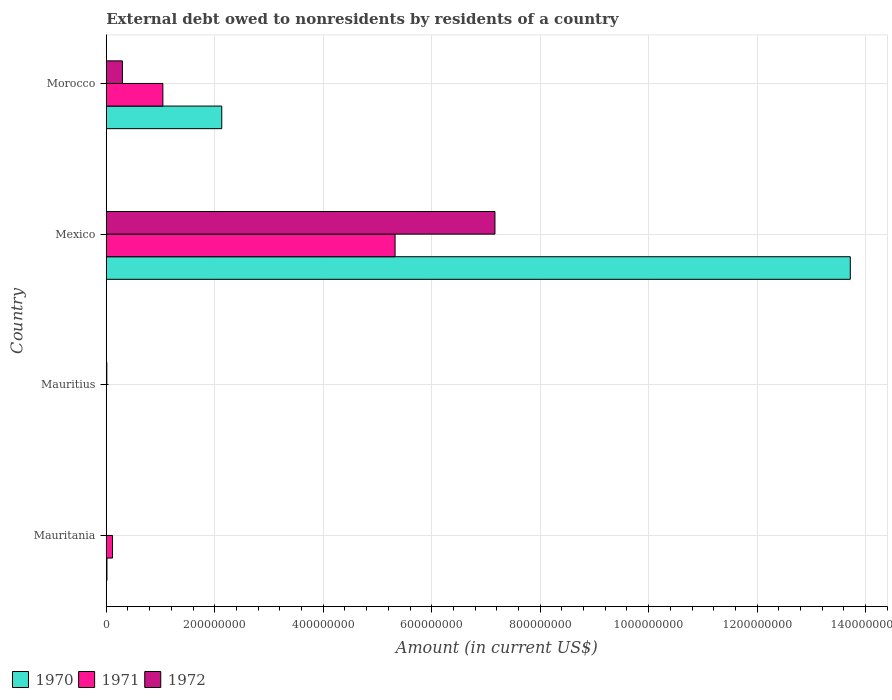How many different coloured bars are there?
Your response must be concise. 3. Are the number of bars on each tick of the Y-axis equal?
Ensure brevity in your answer.  No. How many bars are there on the 4th tick from the bottom?
Your answer should be compact. 3. In how many cases, is the number of bars for a given country not equal to the number of legend labels?
Keep it short and to the point. 2. What is the external debt owed by residents in 1970 in Mauritius?
Your response must be concise. 0. Across all countries, what is the maximum external debt owed by residents in 1971?
Give a very brief answer. 5.32e+08. In which country was the external debt owed by residents in 1970 maximum?
Your answer should be compact. Mexico. What is the total external debt owed by residents in 1970 in the graph?
Ensure brevity in your answer.  1.59e+09. What is the difference between the external debt owed by residents in 1971 in Mauritania and that in Morocco?
Offer a terse response. -9.29e+07. What is the difference between the external debt owed by residents in 1971 in Mauritius and the external debt owed by residents in 1970 in Morocco?
Your answer should be very brief. -2.13e+08. What is the average external debt owed by residents in 1971 per country?
Your answer should be compact. 1.62e+08. What is the difference between the external debt owed by residents in 1970 and external debt owed by residents in 1972 in Morocco?
Offer a very short reply. 1.83e+08. What is the ratio of the external debt owed by residents in 1972 in Mauritius to that in Mexico?
Your answer should be compact. 0. Is the external debt owed by residents in 1971 in Mexico less than that in Morocco?
Provide a short and direct response. No. What is the difference between the highest and the second highest external debt owed by residents in 1971?
Ensure brevity in your answer.  4.28e+08. What is the difference between the highest and the lowest external debt owed by residents in 1970?
Give a very brief answer. 1.37e+09. In how many countries, is the external debt owed by residents in 1972 greater than the average external debt owed by residents in 1972 taken over all countries?
Keep it short and to the point. 1. Is the sum of the external debt owed by residents in 1970 in Mauritania and Morocco greater than the maximum external debt owed by residents in 1971 across all countries?
Provide a short and direct response. No. How many bars are there?
Offer a terse response. 9. What is the difference between two consecutive major ticks on the X-axis?
Provide a short and direct response. 2.00e+08. Are the values on the major ticks of X-axis written in scientific E-notation?
Your answer should be very brief. No. Where does the legend appear in the graph?
Your answer should be very brief. Bottom left. How are the legend labels stacked?
Your response must be concise. Horizontal. What is the title of the graph?
Your answer should be very brief. External debt owed to nonresidents by residents of a country. Does "1998" appear as one of the legend labels in the graph?
Provide a short and direct response. No. What is the label or title of the X-axis?
Your answer should be very brief. Amount (in current US$). What is the label or title of the Y-axis?
Keep it short and to the point. Country. What is the Amount (in current US$) in 1970 in Mauritania?
Your answer should be very brief. 1.34e+06. What is the Amount (in current US$) in 1971 in Mauritania?
Your response must be concise. 1.15e+07. What is the Amount (in current US$) in 1972 in Mauritania?
Provide a succinct answer. 0. What is the Amount (in current US$) in 1972 in Mauritius?
Keep it short and to the point. 1.06e+06. What is the Amount (in current US$) in 1970 in Mexico?
Provide a short and direct response. 1.37e+09. What is the Amount (in current US$) of 1971 in Mexico?
Offer a very short reply. 5.32e+08. What is the Amount (in current US$) in 1972 in Mexico?
Make the answer very short. 7.17e+08. What is the Amount (in current US$) of 1970 in Morocco?
Provide a succinct answer. 2.13e+08. What is the Amount (in current US$) of 1971 in Morocco?
Keep it short and to the point. 1.04e+08. What is the Amount (in current US$) of 1972 in Morocco?
Ensure brevity in your answer.  2.98e+07. Across all countries, what is the maximum Amount (in current US$) in 1970?
Ensure brevity in your answer.  1.37e+09. Across all countries, what is the maximum Amount (in current US$) in 1971?
Your answer should be compact. 5.32e+08. Across all countries, what is the maximum Amount (in current US$) in 1972?
Your response must be concise. 7.17e+08. Across all countries, what is the minimum Amount (in current US$) in 1970?
Ensure brevity in your answer.  0. Across all countries, what is the minimum Amount (in current US$) of 1972?
Provide a succinct answer. 0. What is the total Amount (in current US$) in 1970 in the graph?
Make the answer very short. 1.59e+09. What is the total Amount (in current US$) in 1971 in the graph?
Your response must be concise. 6.48e+08. What is the total Amount (in current US$) in 1972 in the graph?
Offer a terse response. 7.47e+08. What is the difference between the Amount (in current US$) of 1970 in Mauritania and that in Mexico?
Provide a succinct answer. -1.37e+09. What is the difference between the Amount (in current US$) of 1971 in Mauritania and that in Mexico?
Keep it short and to the point. -5.21e+08. What is the difference between the Amount (in current US$) of 1970 in Mauritania and that in Morocco?
Provide a short and direct response. -2.12e+08. What is the difference between the Amount (in current US$) of 1971 in Mauritania and that in Morocco?
Offer a terse response. -9.29e+07. What is the difference between the Amount (in current US$) in 1972 in Mauritius and that in Mexico?
Offer a terse response. -7.16e+08. What is the difference between the Amount (in current US$) in 1972 in Mauritius and that in Morocco?
Your response must be concise. -2.88e+07. What is the difference between the Amount (in current US$) in 1970 in Mexico and that in Morocco?
Your answer should be compact. 1.16e+09. What is the difference between the Amount (in current US$) of 1971 in Mexico and that in Morocco?
Keep it short and to the point. 4.28e+08. What is the difference between the Amount (in current US$) in 1972 in Mexico and that in Morocco?
Provide a short and direct response. 6.87e+08. What is the difference between the Amount (in current US$) in 1970 in Mauritania and the Amount (in current US$) in 1972 in Mauritius?
Offer a terse response. 2.82e+05. What is the difference between the Amount (in current US$) of 1971 in Mauritania and the Amount (in current US$) of 1972 in Mauritius?
Offer a very short reply. 1.05e+07. What is the difference between the Amount (in current US$) of 1970 in Mauritania and the Amount (in current US$) of 1971 in Mexico?
Offer a very short reply. -5.31e+08. What is the difference between the Amount (in current US$) of 1970 in Mauritania and the Amount (in current US$) of 1972 in Mexico?
Offer a very short reply. -7.15e+08. What is the difference between the Amount (in current US$) of 1971 in Mauritania and the Amount (in current US$) of 1972 in Mexico?
Your answer should be very brief. -7.05e+08. What is the difference between the Amount (in current US$) of 1970 in Mauritania and the Amount (in current US$) of 1971 in Morocco?
Provide a short and direct response. -1.03e+08. What is the difference between the Amount (in current US$) of 1970 in Mauritania and the Amount (in current US$) of 1972 in Morocco?
Offer a very short reply. -2.85e+07. What is the difference between the Amount (in current US$) of 1971 in Mauritania and the Amount (in current US$) of 1972 in Morocco?
Ensure brevity in your answer.  -1.83e+07. What is the difference between the Amount (in current US$) in 1970 in Mexico and the Amount (in current US$) in 1971 in Morocco?
Your answer should be very brief. 1.27e+09. What is the difference between the Amount (in current US$) in 1970 in Mexico and the Amount (in current US$) in 1972 in Morocco?
Your answer should be compact. 1.34e+09. What is the difference between the Amount (in current US$) of 1971 in Mexico and the Amount (in current US$) of 1972 in Morocco?
Provide a short and direct response. 5.03e+08. What is the average Amount (in current US$) in 1970 per country?
Your answer should be very brief. 3.97e+08. What is the average Amount (in current US$) of 1971 per country?
Offer a terse response. 1.62e+08. What is the average Amount (in current US$) in 1972 per country?
Provide a short and direct response. 1.87e+08. What is the difference between the Amount (in current US$) of 1970 and Amount (in current US$) of 1971 in Mauritania?
Your answer should be compact. -1.02e+07. What is the difference between the Amount (in current US$) in 1970 and Amount (in current US$) in 1971 in Mexico?
Your answer should be very brief. 8.39e+08. What is the difference between the Amount (in current US$) in 1970 and Amount (in current US$) in 1972 in Mexico?
Offer a very short reply. 6.55e+08. What is the difference between the Amount (in current US$) of 1971 and Amount (in current US$) of 1972 in Mexico?
Your answer should be compact. -1.84e+08. What is the difference between the Amount (in current US$) of 1970 and Amount (in current US$) of 1971 in Morocco?
Ensure brevity in your answer.  1.09e+08. What is the difference between the Amount (in current US$) in 1970 and Amount (in current US$) in 1972 in Morocco?
Your answer should be very brief. 1.83e+08. What is the difference between the Amount (in current US$) in 1971 and Amount (in current US$) in 1972 in Morocco?
Give a very brief answer. 7.46e+07. What is the ratio of the Amount (in current US$) in 1971 in Mauritania to that in Mexico?
Your response must be concise. 0.02. What is the ratio of the Amount (in current US$) of 1970 in Mauritania to that in Morocco?
Provide a short and direct response. 0.01. What is the ratio of the Amount (in current US$) of 1971 in Mauritania to that in Morocco?
Offer a terse response. 0.11. What is the ratio of the Amount (in current US$) in 1972 in Mauritius to that in Mexico?
Offer a terse response. 0. What is the ratio of the Amount (in current US$) of 1972 in Mauritius to that in Morocco?
Give a very brief answer. 0.04. What is the ratio of the Amount (in current US$) of 1970 in Mexico to that in Morocco?
Offer a very short reply. 6.44. What is the ratio of the Amount (in current US$) in 1971 in Mexico to that in Morocco?
Your answer should be very brief. 5.1. What is the ratio of the Amount (in current US$) of 1972 in Mexico to that in Morocco?
Make the answer very short. 24.03. What is the difference between the highest and the second highest Amount (in current US$) of 1970?
Ensure brevity in your answer.  1.16e+09. What is the difference between the highest and the second highest Amount (in current US$) in 1971?
Provide a succinct answer. 4.28e+08. What is the difference between the highest and the second highest Amount (in current US$) in 1972?
Give a very brief answer. 6.87e+08. What is the difference between the highest and the lowest Amount (in current US$) in 1970?
Provide a succinct answer. 1.37e+09. What is the difference between the highest and the lowest Amount (in current US$) of 1971?
Offer a terse response. 5.32e+08. What is the difference between the highest and the lowest Amount (in current US$) in 1972?
Your answer should be very brief. 7.17e+08. 